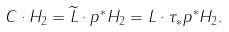<formula> <loc_0><loc_0><loc_500><loc_500>C \cdot H _ { 2 } = \widetilde { L } \cdot p ^ { * } H _ { 2 } = L \cdot \tau _ { * } p ^ { * } H _ { 2 } .</formula> 